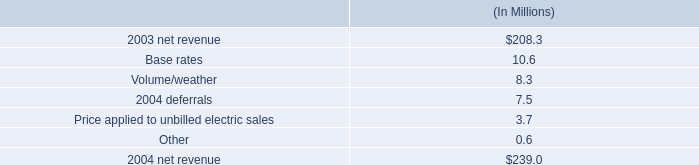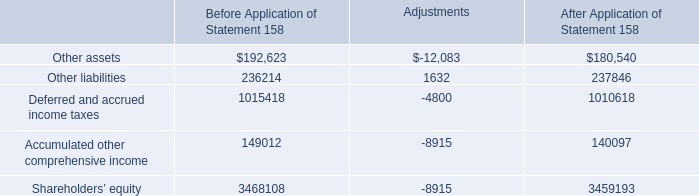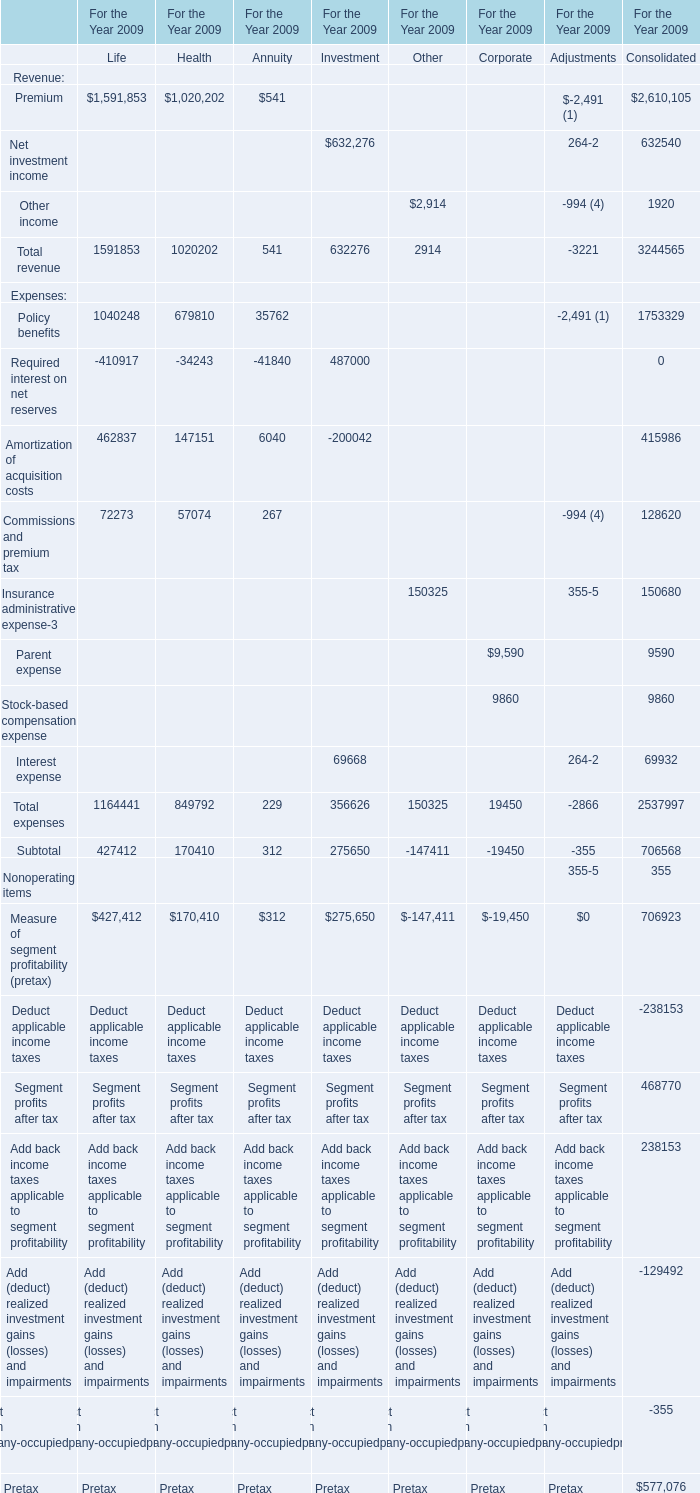what portion of the net change in net revenue during 2004 occurred due to the volume/weather? 
Computations: (8.3 / (239.0 - 208.3))
Answer: 0.27036. 